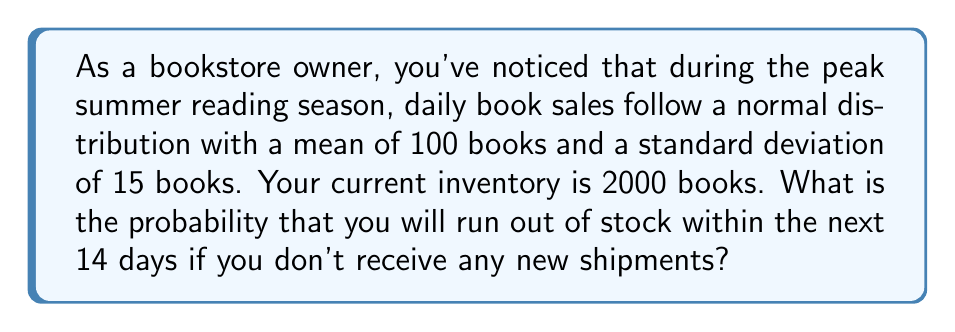Can you answer this question? To solve this problem, we'll follow these steps:

1) First, we need to calculate the total number of books that would need to be sold in 14 days to deplete the inventory:
   2000 books (current inventory)

2) Now, we need to find the mean and standard deviation for book sales over 14 days:
   Daily mean (μ) = 100 books
   14-day mean = 100 * 14 = 1400 books

   Daily standard deviation (σ) = 15 books
   14-day standard deviation = $15 * \sqrt{14} \approx 56.12$ books

3) We want to find the probability of selling more than 2000 books in 14 days. We can use the z-score formula:

   $z = \frac{x - μ}{σ}$

   Where x is our inventory (2000), μ is our 14-day mean (1400), and σ is our 14-day standard deviation (56.12).

4) Plugging in the values:

   $z = \frac{2000 - 1400}{56.12} \approx 10.69$

5) This z-score represents the number of standard deviations above the mean where our inventory lies. We need to find the probability of exceeding this z-score.

6) Using a standard normal distribution table or calculator, we find:

   $P(Z > 10.69) \approx 5.12 * 10^{-27}$

7) Therefore, the probability of running out of stock is extremely low, approximately $5.12 * 10^{-27}$ or 0.000000000000000000000000512%
Answer: $5.12 * 10^{-27}$ 